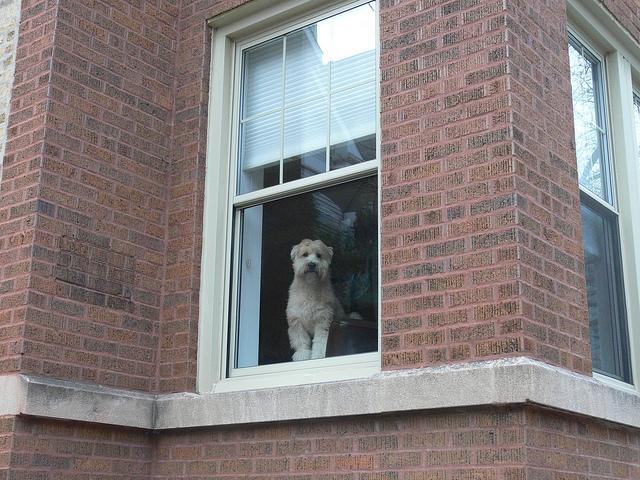What kind of dog is looking out the window?
Short answer required. Terrier. What color is this dog?
Quick response, please. White. Is this animal on the first floor?
Answer briefly. No. What animal is this?
Give a very brief answer. Dog. Is this animal indoors?
Keep it brief. Yes. Are all the bricks the same color?
Be succinct. No. 